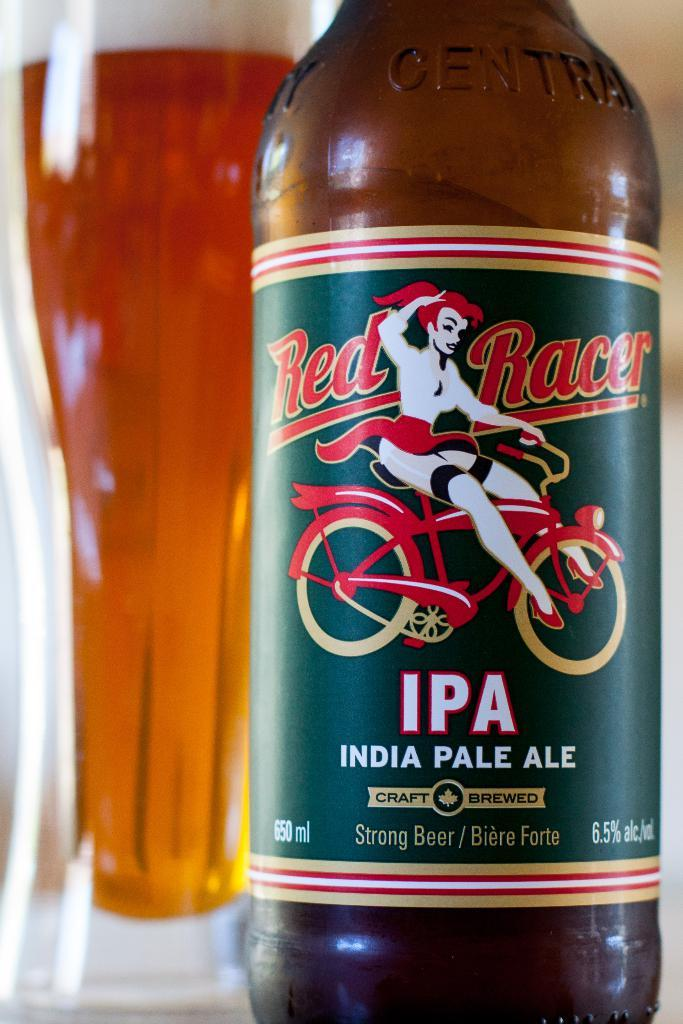<image>
Present a compact description of the photo's key features. Bottle of Red Racer IPA with a girl riding a bicycle on the label. 